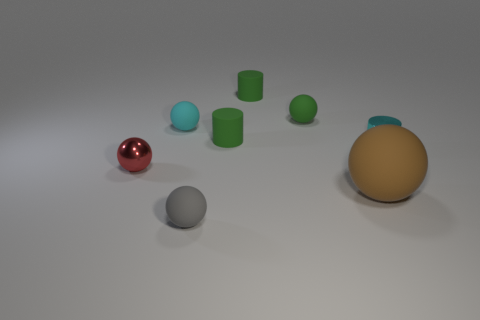Subtract all small rubber cylinders. How many cylinders are left? 1 Add 1 big green rubber objects. How many objects exist? 9 Subtract all balls. How many objects are left? 3 Subtract all brown spheres. How many spheres are left? 4 Subtract 1 cylinders. How many cylinders are left? 2 Subtract all blue cylinders. Subtract all red cubes. How many cylinders are left? 3 Subtract all cyan spheres. How many blue cylinders are left? 0 Subtract all tiny gray spheres. Subtract all green rubber objects. How many objects are left? 4 Add 5 tiny balls. How many tiny balls are left? 9 Add 1 small cyan rubber balls. How many small cyan rubber balls exist? 2 